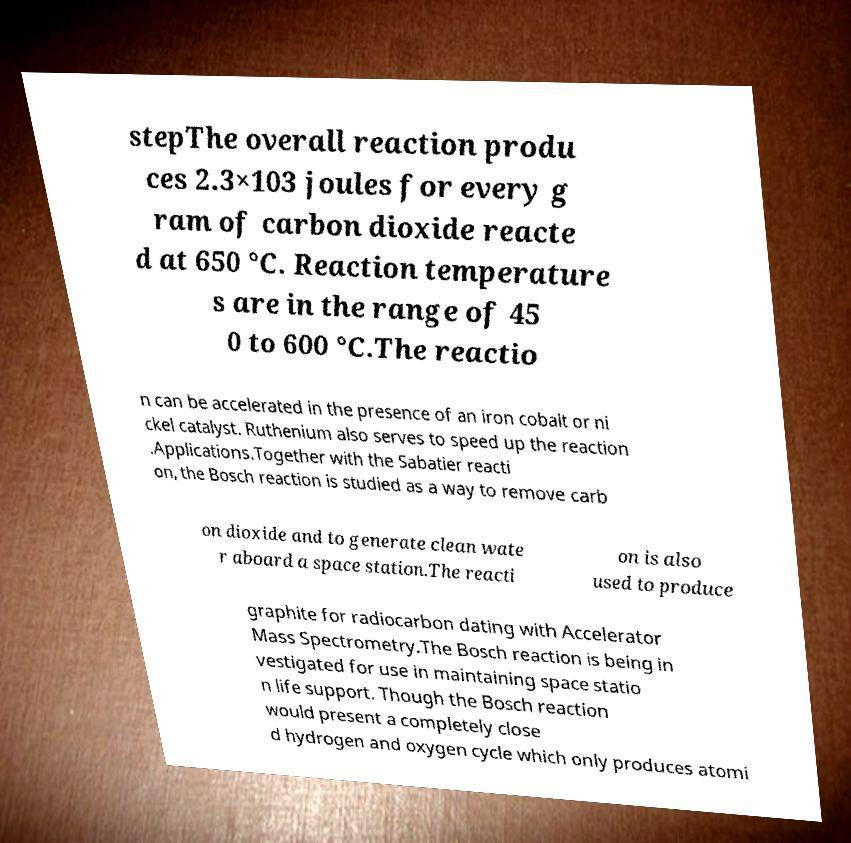Could you extract and type out the text from this image? stepThe overall reaction produ ces 2.3×103 joules for every g ram of carbon dioxide reacte d at 650 °C. Reaction temperature s are in the range of 45 0 to 600 °C.The reactio n can be accelerated in the presence of an iron cobalt or ni ckel catalyst. Ruthenium also serves to speed up the reaction .Applications.Together with the Sabatier reacti on, the Bosch reaction is studied as a way to remove carb on dioxide and to generate clean wate r aboard a space station.The reacti on is also used to produce graphite for radiocarbon dating with Accelerator Mass Spectrometry.The Bosch reaction is being in vestigated for use in maintaining space statio n life support. Though the Bosch reaction would present a completely close d hydrogen and oxygen cycle which only produces atomi 